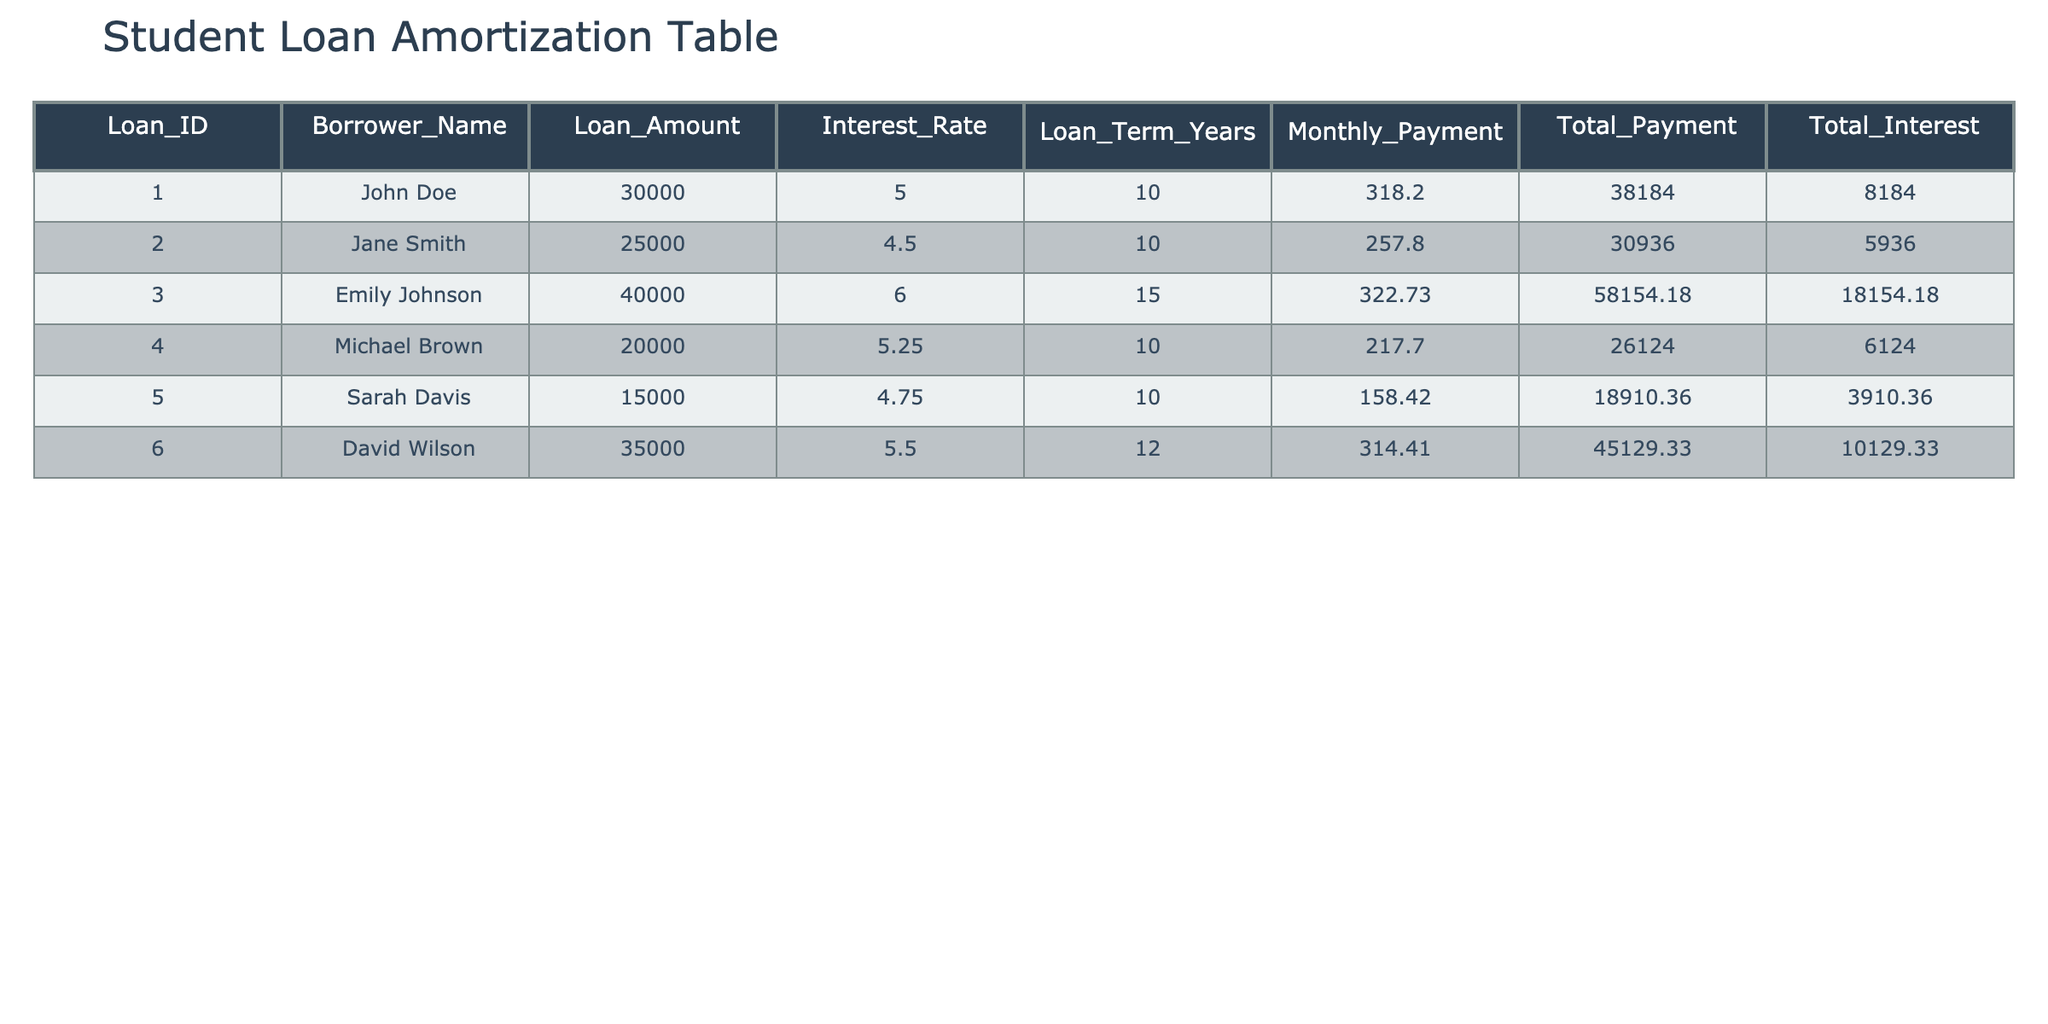What is the loan amount for John Doe? The table shows the loan amounts listed under the "Loan_Amount" column. For John Doe, the corresponding loan amount in the "Loan_Amount" column is 30000.
Answer: 30000 What is the total payment amount for Emily Johnson? To find the total payment for Emily Johnson, we refer to the "Total_Payment" column in the table. Emily Johnson is listed as having a total payment of 58154.18.
Answer: 58154.18 Is Sarah Davis’s interest rate lower than David Wilson’s? From the table, Sarah Davis has an interest rate of 4.75, while David Wilson has an interest rate of 5.50. Since 4.75 is less than 5.50, the answer is yes.
Answer: Yes Which borrower has the highest total interest? Looking at the "Total_Interest" column, we find the values: John Doe (8184.00), Jane Smith (5936.00), Emily Johnson (18154.18), Michael Brown (6124.00), Sarah Davis (3910.36), and David Wilson (10129.33). The highest total interest is associated with Emily Johnson, at 18154.18.
Answer: Emily Johnson What is the average loan amount across all borrowers? First, we sum the loan amounts: 30000 + 25000 + 40000 + 20000 + 15000 + 35000 = 165000. There are 6 borrowers, so the average is 165000 / 6 = 27500.
Answer: 27500 What is the difference in total payment between Jane Smith and Michael Brown? Jane Smith's total payment is 30936.00 and Michael Brown's total payment is 26124.00. To find the difference, we subtract: 30936.00 - 26124.00 = 4812.00.
Answer: 4812.00 Does any borrower have an interest rate of 5.00%? Checking the "Interest_Rate" column, we see that John Doe is the only borrower listed with an interest rate of 5.00%. Therefore, the answer is yes.
Answer: Yes Who has the lowest monthly payment among all the borrowers? The monthly payments are listed as follows: John Doe (318.20), Jane Smith (257.80), Emily Johnson (322.73), Michael Brown (217.70), Sarah Davis (158.42), and David Wilson (314.41). The lowest monthly payment is for Sarah Davis, at 158.42.
Answer: Sarah Davis What is the total amount of interest paid for all loans combined? We sum the total interest amounts: 8184.00 + 5936.00 + 18154.18 + 6124.00 + 3910.36 + 10129.33 = 40337.87. This gives us the total interest paid for all loans combined.
Answer: 40337.87 